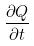<formula> <loc_0><loc_0><loc_500><loc_500>\frac { \partial Q } { \partial t }</formula> 